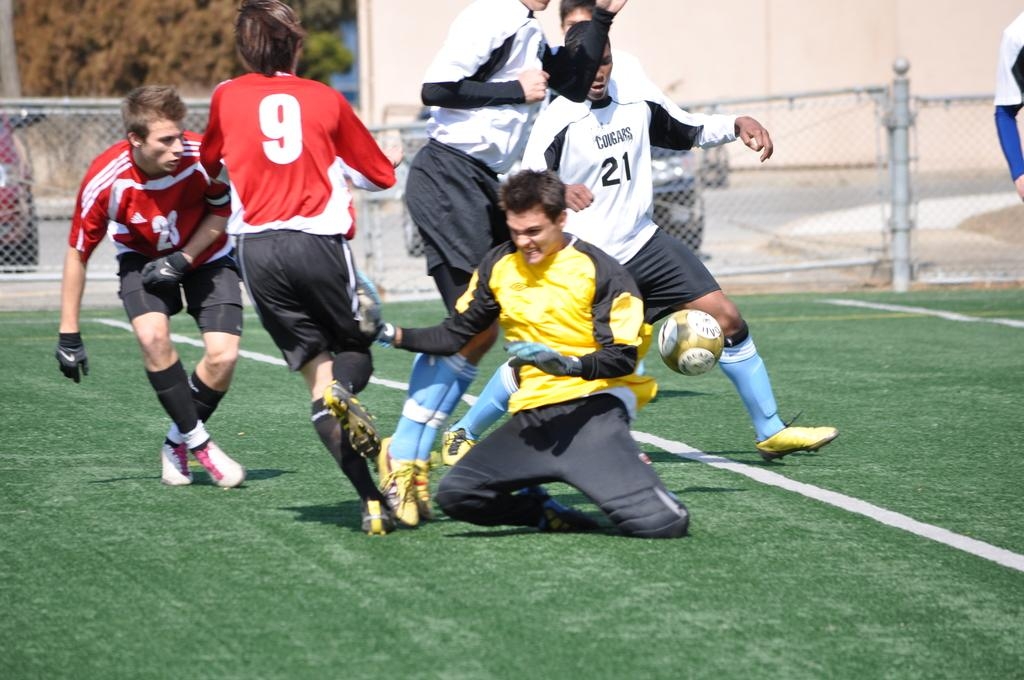<image>
Give a short and clear explanation of the subsequent image. Player number 9 is just about to trip over another players' feet. 